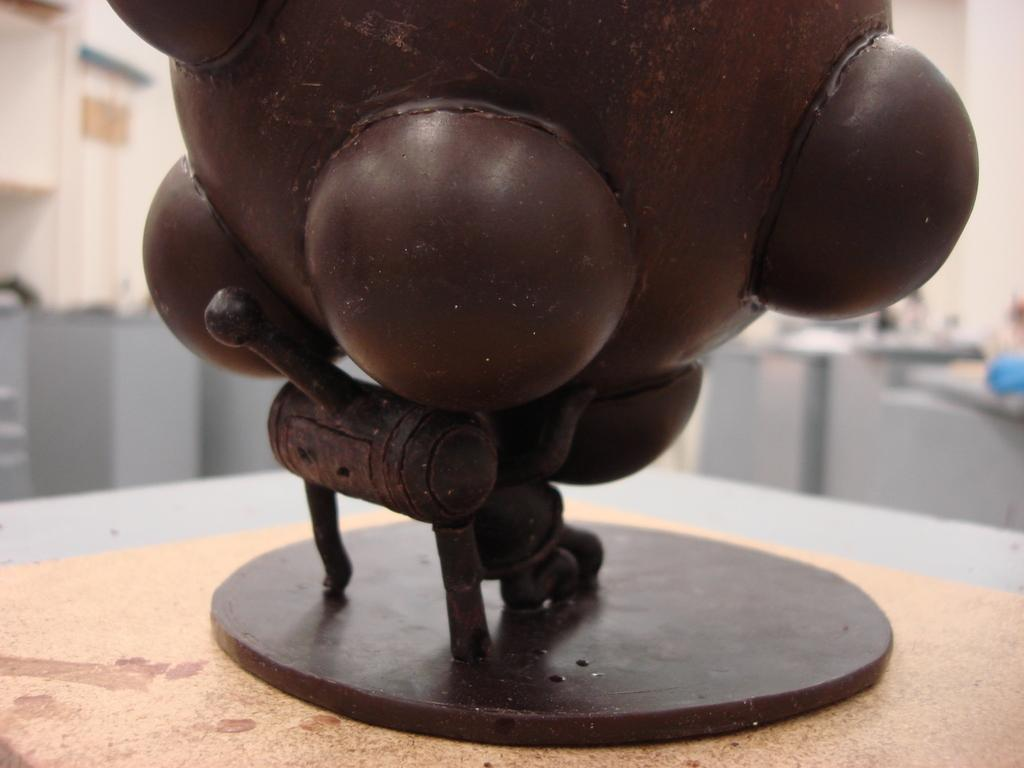What type of material is the main object in the image made of? The main object in the image is made of metal. Where is the metal object located? The metal object is on a platform. What can be seen in the background of the image? There is a wall visible in the background of the image, and there are other objects present as well. How many legs does the metal object have in the image? The metal object in the image does not have legs; it is stationary on the platform. Is there a crown visible on the wall in the background of the image? There is no crown visible in the image; only a wall and other objects are present in the background. 